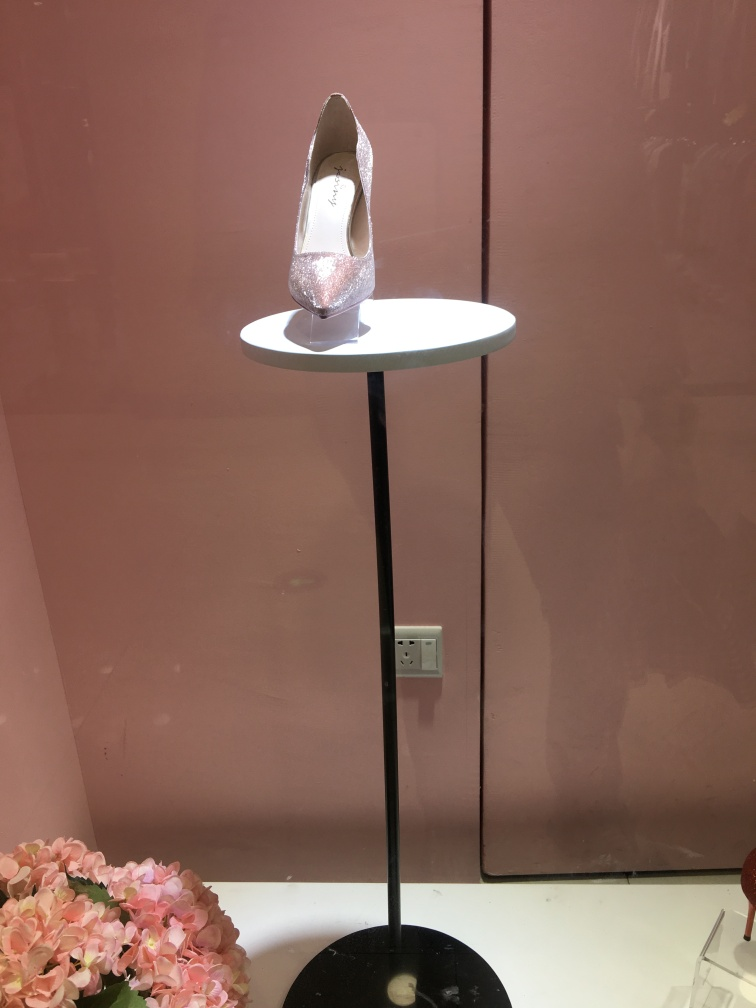What can be inferred about the shoe's target consumer? Based on the glamorous appearance and prominent display of the shoe, it likely targets consumers interested in fashion-forward, elegant footwear. The shoe's aesthetic hints at a formal or event wear market, suggesting the consumer may be someone looking for a bold statement piece for special occasions. 